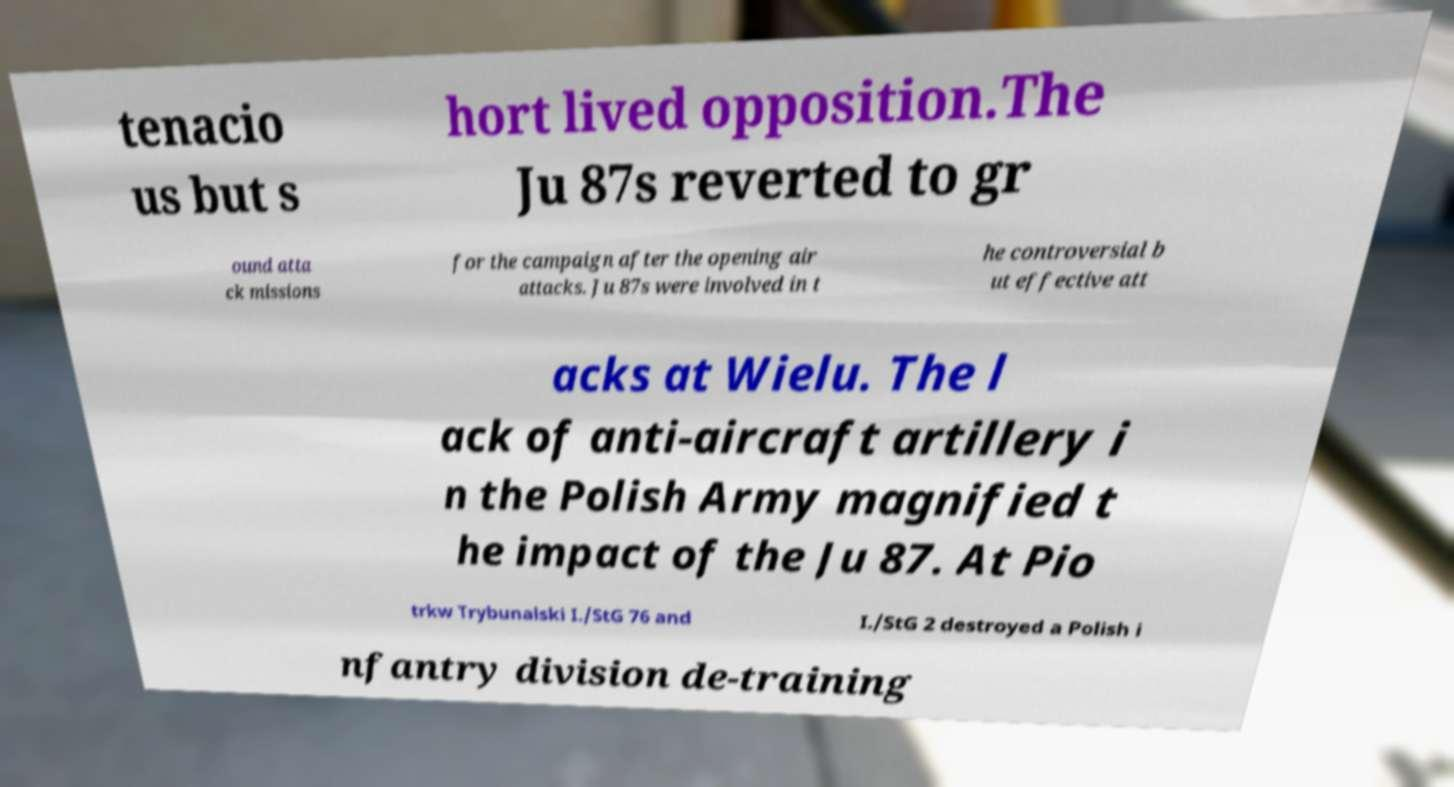Can you read and provide the text displayed in the image?This photo seems to have some interesting text. Can you extract and type it out for me? tenacio us but s hort lived opposition.The Ju 87s reverted to gr ound atta ck missions for the campaign after the opening air attacks. Ju 87s were involved in t he controversial b ut effective att acks at Wielu. The l ack of anti-aircraft artillery i n the Polish Army magnified t he impact of the Ju 87. At Pio trkw Trybunalski I./StG 76 and I./StG 2 destroyed a Polish i nfantry division de-training 